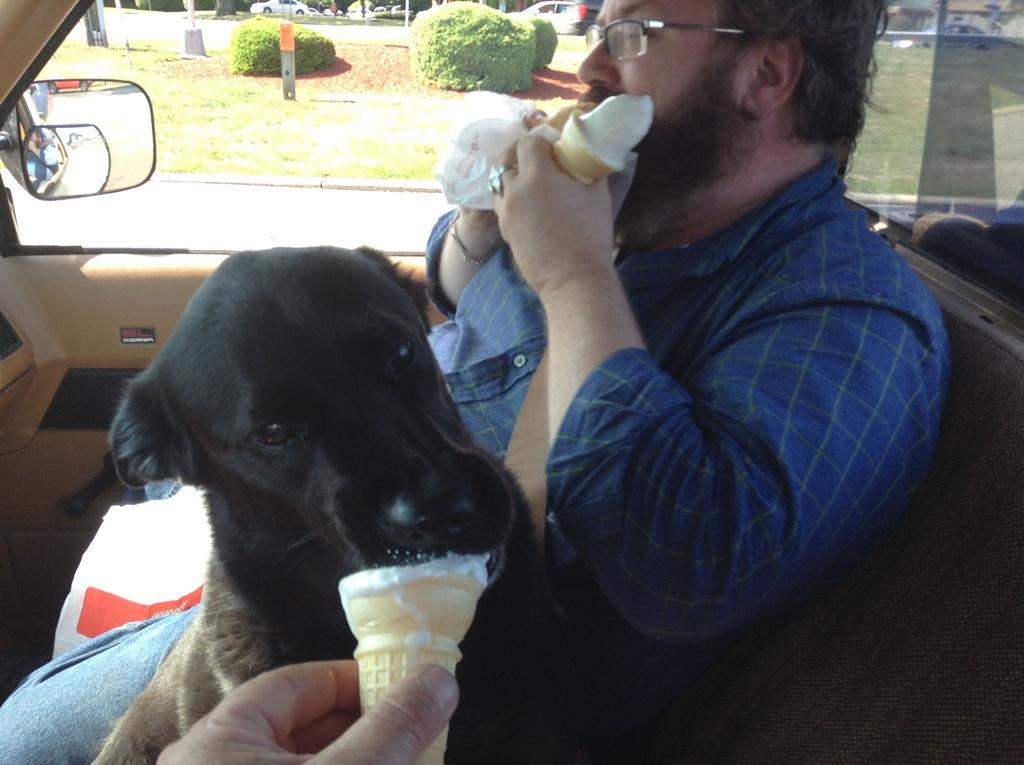Who or what is present in the image? There is a person and a dog in the image. What are the person and the dog doing in the image? The person and the dog are eating ice cream. What else can be seen in the image? There is a vehicle in the image. How many stitches are visible on the dog's collar in the image? There is no mention of a collar or stitches on the dog in the image. Can you tell me how many planes are flying in the background of the image? There is no mention of planes or a background in the image. 